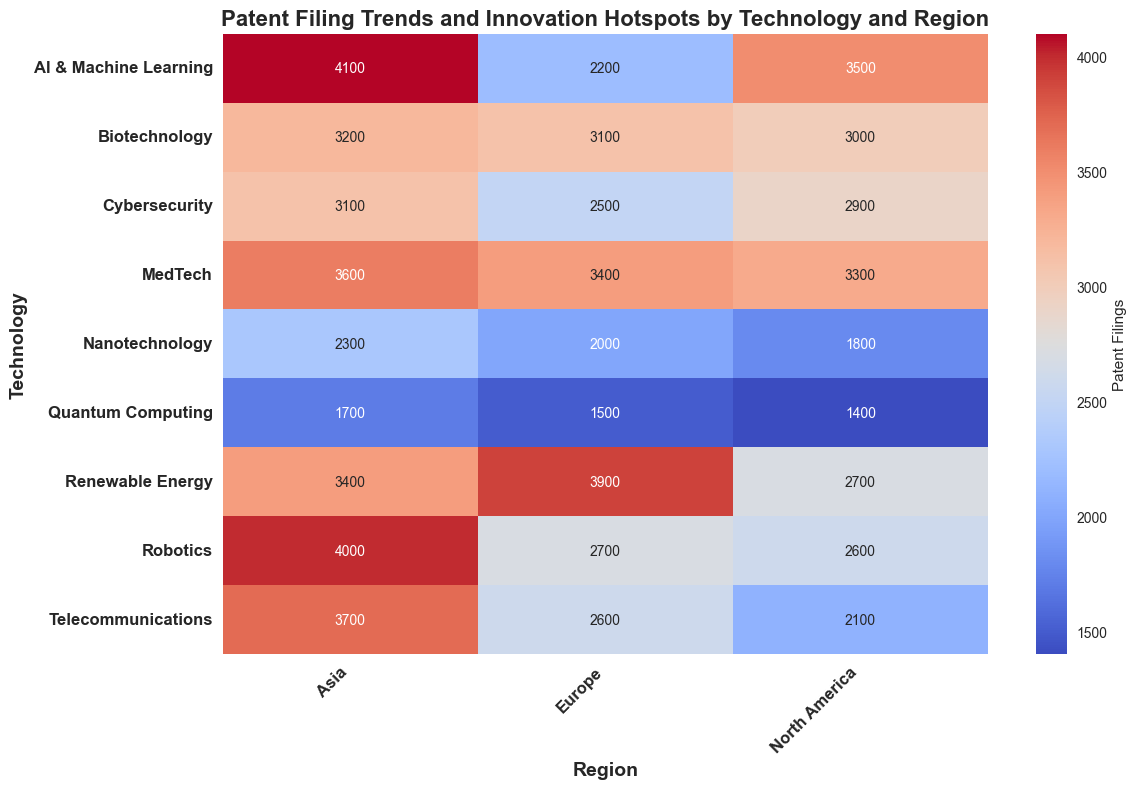Which technology has the highest number of patent filings in Asia? To determine the technology with the highest patent filings in Asia, look for the highest numerical value in the "Asia" column. The highest value is 4100, which corresponds to "AI & Machine Learning."
Answer: AI & Machine Learning Which region has the lowest number of patent filings for Quantum Computing? Examine the "Quantum Computing" row and compare the values in the "North America," "Europe," and "Asia" columns. The lowest value is 1400 in "North America."
Answer: North America What is the total number of patent filings for Biotechnology across all regions? Sum the values in the "Biotechnology" row: 3000 (North America) + 3100 (Europe) + 3200 (Asia) = 9300.
Answer: 9300 In which region is Renewable Energy the leading technology by the number of patent filings? Compare the "Renewable Energy" values across all regions with other technologies in the same regions. In Europe, Renewable Energy has the highest value (3900) compared to other technologies in the same region.
Answer: Europe Which technology has a higher number of patent filings in Europe, Cybersecurity or MedTech? Compare the numbers in the "Europe" column for "Cybersecurity" (2500) and "MedTech" (3400). MedTech has a higher value.
Answer: MedTech What is the average number of patent filings for Robotics across all regions? Calculate the average by summing the values in the "Robotics" row and dividing by the number of regions: (2600 + 2700 + 4000) / 3 = 3100.
Answer: 3100 Which region has the most significant disparity in patent filings for different technologies? Compare the range (difference between max and min values) in patent filings for each region. In Asia, the range is the highest: 4100 (AI & Machine Learning) - 1700 (Quantum Computing) = 2400.
Answer: Asia Between North America and Europe, which region has more patent filings for Telecommunications? Compare the values in the "Telecommunications" row for North America (2100) and Europe (2600). Europe has more filings.
Answer: Europe Which technology has the darkest cell in the heatmap in the Asia region, and what does it indicate? The darkest cell in the Asia region corresponds to Quantum Computing with a value of 1700. Dark colors in the heatmap typically represent lower values, indicating fewer patent filings in Quantum Computing in Asia.
Answer: Quantum Computing What is the difference in patent filings for MedTech between Europe and Asia? Subtract the value in the "MedTech" row for Europe from that of Asia: 3600 (Asia) - 3400 (Europe) = 200.
Answer: 200 